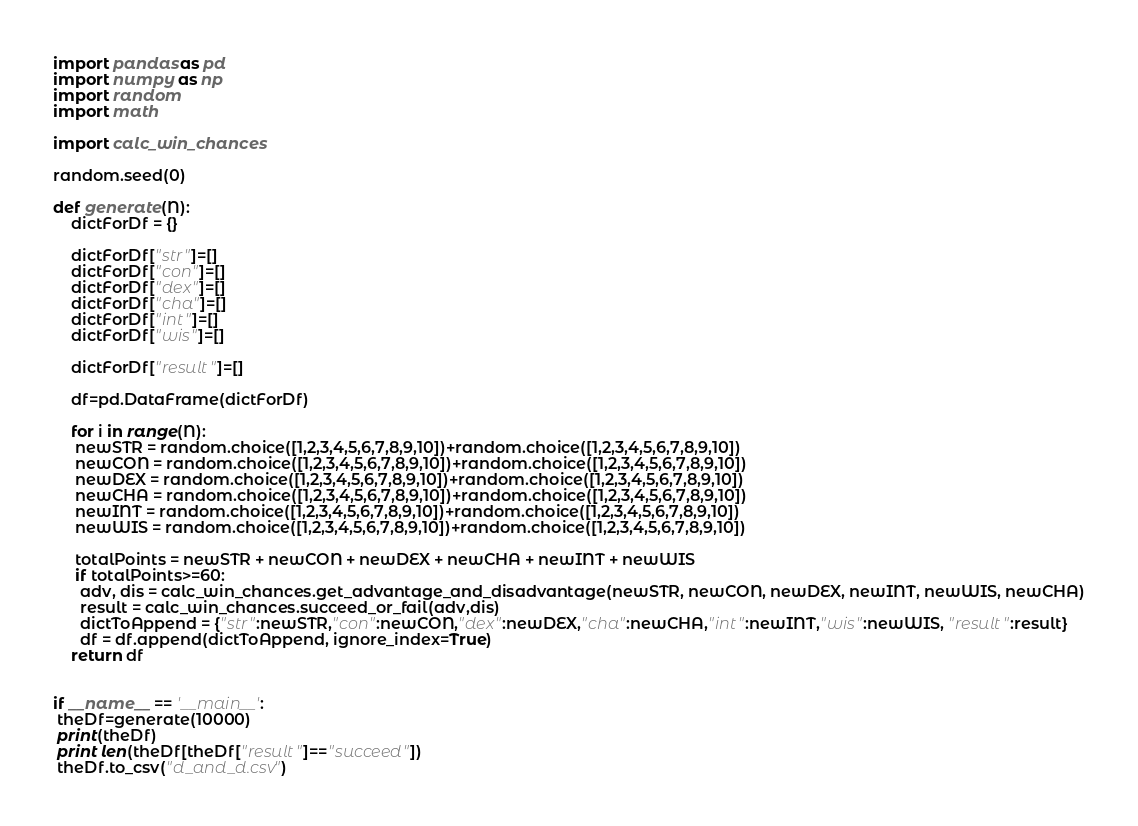Convert code to text. <code><loc_0><loc_0><loc_500><loc_500><_Python_>import pandas as pd
import numpy as np
import random
import math

import calc_win_chances

random.seed(0)

def generate(N):
    dictForDf = {}

    dictForDf["str"]=[]
    dictForDf["con"]=[]
    dictForDf["dex"]=[]
    dictForDf["cha"]=[]
    dictForDf["int"]=[]
    dictForDf["wis"]=[]
    
    dictForDf["result"]=[]

    df=pd.DataFrame(dictForDf)

    for i in range(N):
     newSTR = random.choice([1,2,3,4,5,6,7,8,9,10])+random.choice([1,2,3,4,5,6,7,8,9,10])
     newCON = random.choice([1,2,3,4,5,6,7,8,9,10])+random.choice([1,2,3,4,5,6,7,8,9,10])
     newDEX = random.choice([1,2,3,4,5,6,7,8,9,10])+random.choice([1,2,3,4,5,6,7,8,9,10])
     newCHA = random.choice([1,2,3,4,5,6,7,8,9,10])+random.choice([1,2,3,4,5,6,7,8,9,10])
     newINT = random.choice([1,2,3,4,5,6,7,8,9,10])+random.choice([1,2,3,4,5,6,7,8,9,10])
     newWIS = random.choice([1,2,3,4,5,6,7,8,9,10])+random.choice([1,2,3,4,5,6,7,8,9,10])

     totalPoints = newSTR + newCON + newDEX + newCHA + newINT + newWIS
     if totalPoints>=60:
      adv, dis = calc_win_chances.get_advantage_and_disadvantage(newSTR, newCON, newDEX, newINT, newWIS, newCHA)
      result = calc_win_chances.succeed_or_fail(adv,dis)
      dictToAppend = {"str":newSTR,"con":newCON,"dex":newDEX,"cha":newCHA,"int":newINT,"wis":newWIS, "result":result}
      df = df.append(dictToAppend, ignore_index=True)
    return df


if __name__ == '__main__':
 theDf=generate(10000)
 print(theDf)
 print len(theDf[theDf["result"]=="succeed"])
 theDf.to_csv("d_and_d.csv")
</code> 